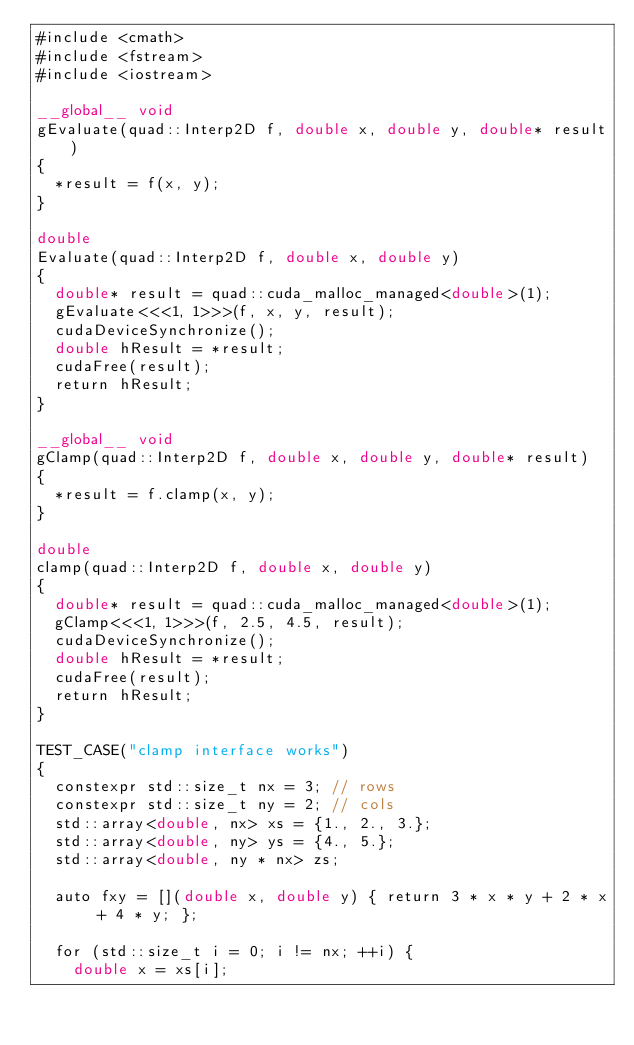<code> <loc_0><loc_0><loc_500><loc_500><_Cuda_>#include <cmath>
#include <fstream>
#include <iostream>

__global__ void
gEvaluate(quad::Interp2D f, double x, double y, double* result)
{
  *result = f(x, y);
}

double
Evaluate(quad::Interp2D f, double x, double y)
{
  double* result = quad::cuda_malloc_managed<double>(1);
  gEvaluate<<<1, 1>>>(f, x, y, result);
  cudaDeviceSynchronize();
  double hResult = *result;
  cudaFree(result);
  return hResult;
}

__global__ void
gClamp(quad::Interp2D f, double x, double y, double* result)
{
  *result = f.clamp(x, y);
}

double
clamp(quad::Interp2D f, double x, double y)
{
  double* result = quad::cuda_malloc_managed<double>(1);
  gClamp<<<1, 1>>>(f, 2.5, 4.5, result);
  cudaDeviceSynchronize();
  double hResult = *result;
  cudaFree(result);
  return hResult;
}

TEST_CASE("clamp interface works")
{
  constexpr std::size_t nx = 3; // rows
  constexpr std::size_t ny = 2; // cols
  std::array<double, nx> xs = {1., 2., 3.};
  std::array<double, ny> ys = {4., 5.};
  std::array<double, ny * nx> zs;

  auto fxy = [](double x, double y) { return 3 * x * y + 2 * x + 4 * y; };

  for (std::size_t i = 0; i != nx; ++i) {
    double x = xs[i];</code> 